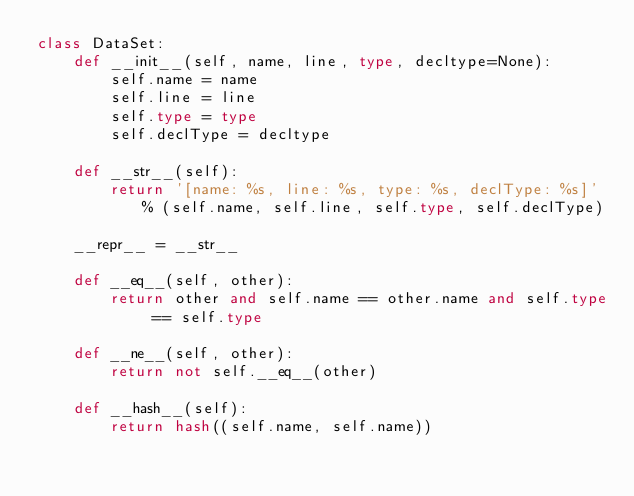<code> <loc_0><loc_0><loc_500><loc_500><_Python_>class DataSet:
    def __init__(self, name, line, type, decltype=None):
        self.name = name
        self.line = line
        self.type = type
        self.declType = decltype

    def __str__(self):
        return '[name: %s, line: %s, type: %s, declType: %s]' % (self.name, self.line, self.type, self.declType)

    __repr__ = __str__

    def __eq__(self, other):
        return other and self.name == other.name and self.type == self.type

    def __ne__(self, other):
        return not self.__eq__(other)

    def __hash__(self):
        return hash((self.name, self.name))
</code> 